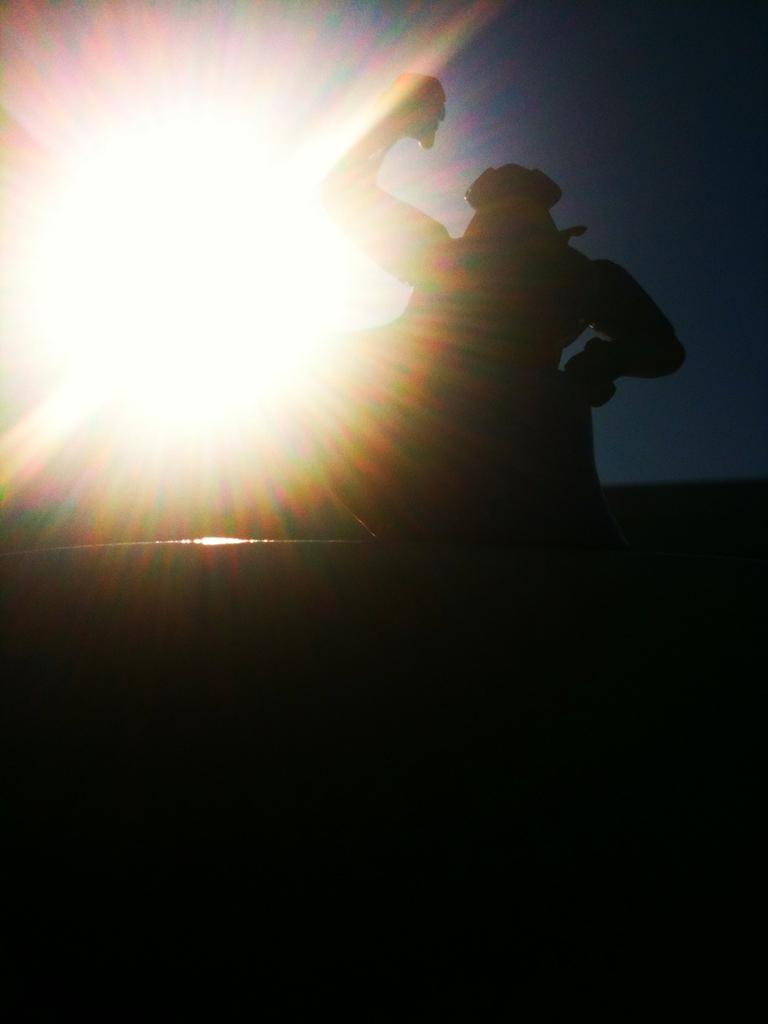Who or what can be seen on the right side of the image? There is a person visible on the right side of the image. What is the source of light on the left side of the image? There is a bright light on the left side of the image. What part of the natural environment is visible in the image? The sky is visible above the bright light. What type of park can be seen in the image? There is no park present in the image. How many spoons are visible in the image? There is no spoon present in the image. 